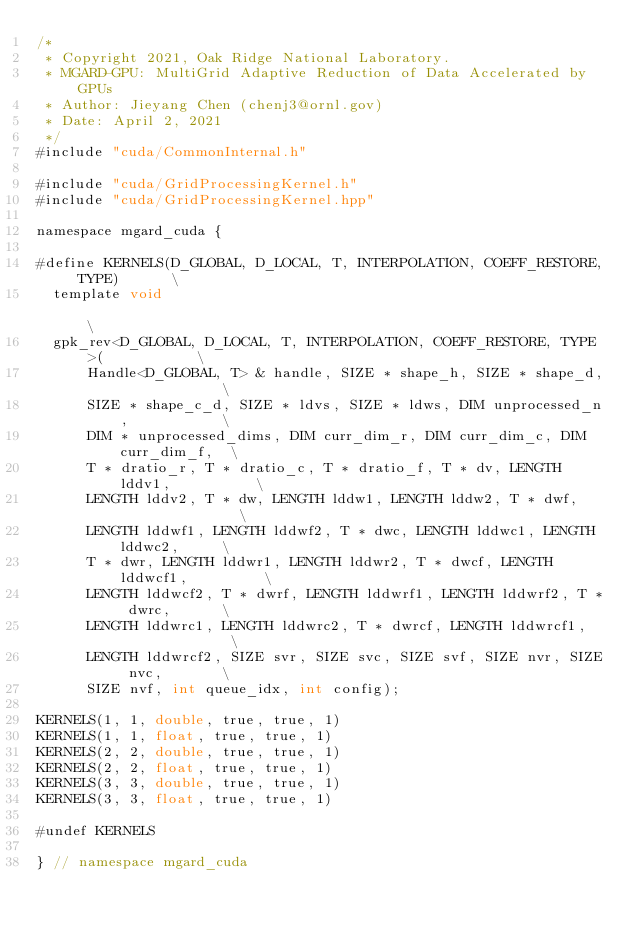<code> <loc_0><loc_0><loc_500><loc_500><_Cuda_>/*
 * Copyright 2021, Oak Ridge National Laboratory.
 * MGARD-GPU: MultiGrid Adaptive Reduction of Data Accelerated by GPUs
 * Author: Jieyang Chen (chenj3@ornl.gov)
 * Date: April 2, 2021
 */
#include "cuda/CommonInternal.h"

#include "cuda/GridProcessingKernel.h"
#include "cuda/GridProcessingKernel.hpp"

namespace mgard_cuda {

#define KERNELS(D_GLOBAL, D_LOCAL, T, INTERPOLATION, COEFF_RESTORE, TYPE)      \
  template void                                                                \
  gpk_rev<D_GLOBAL, D_LOCAL, T, INTERPOLATION, COEFF_RESTORE, TYPE>(           \
      Handle<D_GLOBAL, T> & handle, SIZE * shape_h, SIZE * shape_d,            \
      SIZE * shape_c_d, SIZE * ldvs, SIZE * ldws, DIM unprocessed_n,           \
      DIM * unprocessed_dims, DIM curr_dim_r, DIM curr_dim_c, DIM curr_dim_f,  \
      T * dratio_r, T * dratio_c, T * dratio_f, T * dv, LENGTH lddv1,          \
      LENGTH lddv2, T * dw, LENGTH lddw1, LENGTH lddw2, T * dwf,               \
      LENGTH lddwf1, LENGTH lddwf2, T * dwc, LENGTH lddwc1, LENGTH lddwc2,     \
      T * dwr, LENGTH lddwr1, LENGTH lddwr2, T * dwcf, LENGTH lddwcf1,         \
      LENGTH lddwcf2, T * dwrf, LENGTH lddwrf1, LENGTH lddwrf2, T * dwrc,      \
      LENGTH lddwrc1, LENGTH lddwrc2, T * dwrcf, LENGTH lddwrcf1,              \
      LENGTH lddwrcf2, SIZE svr, SIZE svc, SIZE svf, SIZE nvr, SIZE nvc,       \
      SIZE nvf, int queue_idx, int config);

KERNELS(1, 1, double, true, true, 1)
KERNELS(1, 1, float, true, true, 1)
KERNELS(2, 2, double, true, true, 1)
KERNELS(2, 2, float, true, true, 1)
KERNELS(3, 3, double, true, true, 1)
KERNELS(3, 3, float, true, true, 1)

#undef KERNELS

} // namespace mgard_cuda</code> 